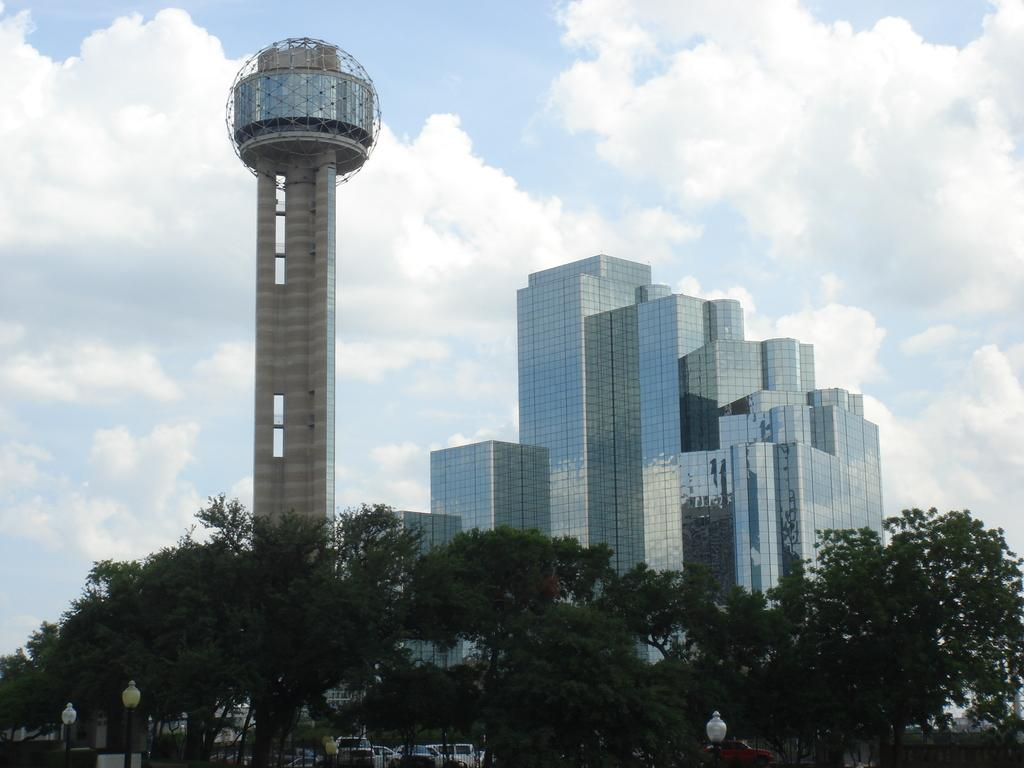What type of structures can be seen in the image? There are buildings in the image. What other natural elements are present in the image? There are trees in the image. What part of the natural environment is visible in the image? The sky is visible in the image. Where is the nest located in the image? There is no nest present in the image. What type of camera is being used to take the picture in the image? There is no camera visible in the image, as it is a photograph of the scene. 